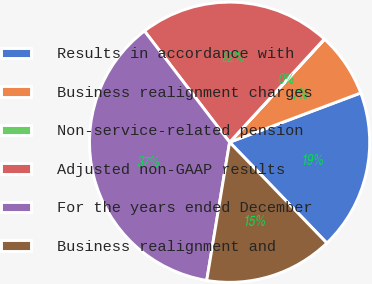Convert chart. <chart><loc_0><loc_0><loc_500><loc_500><pie_chart><fcel>Results in accordance with<fcel>Business realignment charges<fcel>Non-service-related pension<fcel>Adjusted non-GAAP results<fcel>For the years ended December<fcel>Business realignment and<nl><fcel>18.51%<fcel>7.43%<fcel>0.04%<fcel>22.21%<fcel>36.99%<fcel>14.82%<nl></chart> 